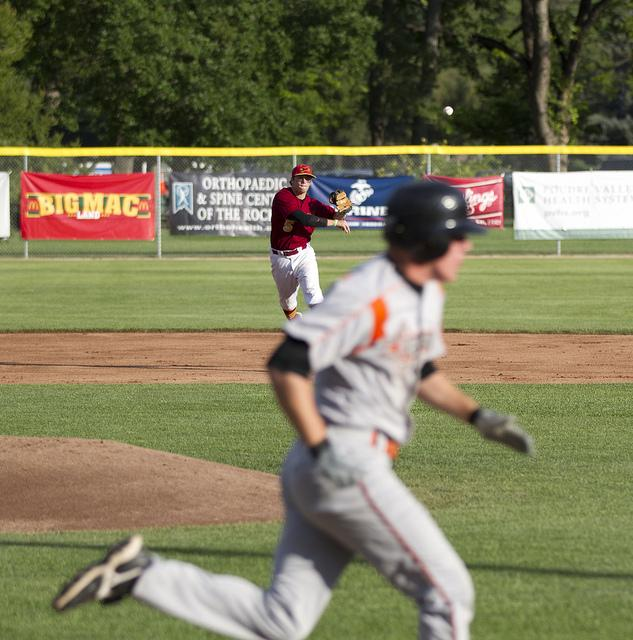Why is the player blurry?

Choices:
A) moving fast
B) bad film
C) broken camera
D) shaky photographer moving fast 